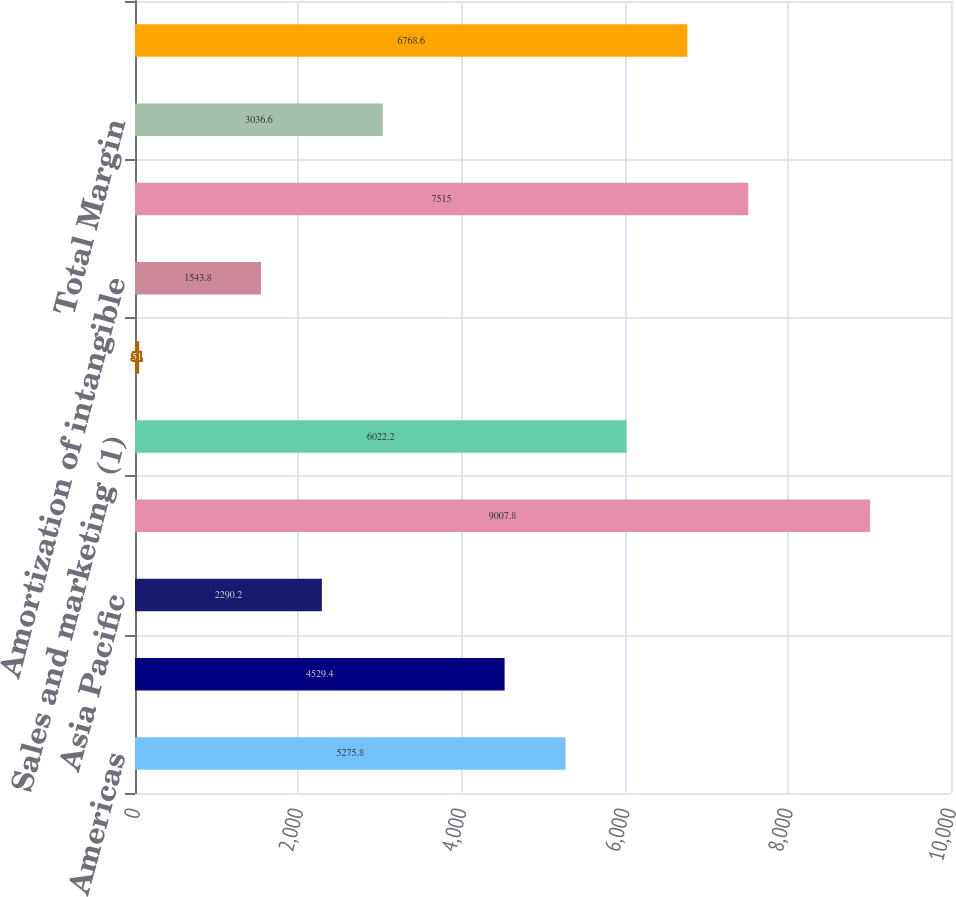<chart> <loc_0><loc_0><loc_500><loc_500><bar_chart><fcel>Americas<fcel>EMEA<fcel>Asia Pacific<fcel>Total revenues<fcel>Sales and marketing (1)<fcel>Stock-based compensation<fcel>Amortization of intangible<fcel>Total expenses<fcel>Total Margin<fcel>Database and middleware<nl><fcel>5275.8<fcel>4529.4<fcel>2290.2<fcel>9007.8<fcel>6022.2<fcel>51<fcel>1543.8<fcel>7515<fcel>3036.6<fcel>6768.6<nl></chart> 